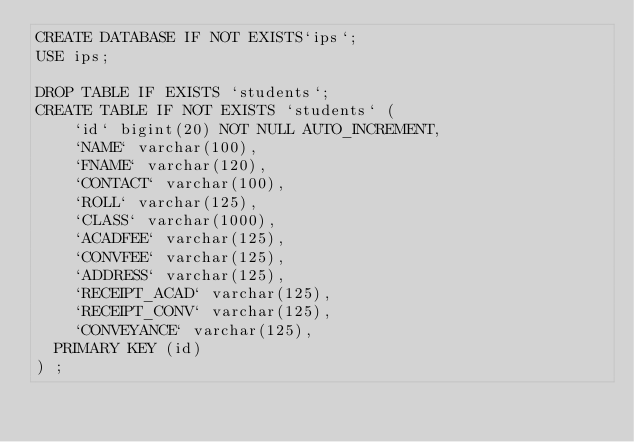Convert code to text. <code><loc_0><loc_0><loc_500><loc_500><_SQL_>CREATE DATABASE IF NOT EXISTS`ips`;
USE ips;

DROP TABLE IF EXISTS `students`;
CREATE TABLE IF NOT EXISTS `students` (
  	`id` bigint(20) NOT NULL AUTO_INCREMENT,
	  `NAME` varchar(100),
   	`FNAME` varchar(120),
   	`CONTACT` varchar(100),
   	`ROLL` varchar(125),
   	`CLASS` varchar(1000),
   	`ACADFEE` varchar(125),
   	`CONVFEE` varchar(125),
		`ADDRESS` varchar(125),
		`RECEIPT_ACAD` varchar(125),
		`RECEIPT_CONV` varchar(125),
		`CONVEYANCE` varchar(125),
  PRIMARY KEY (id)
) ;</code> 